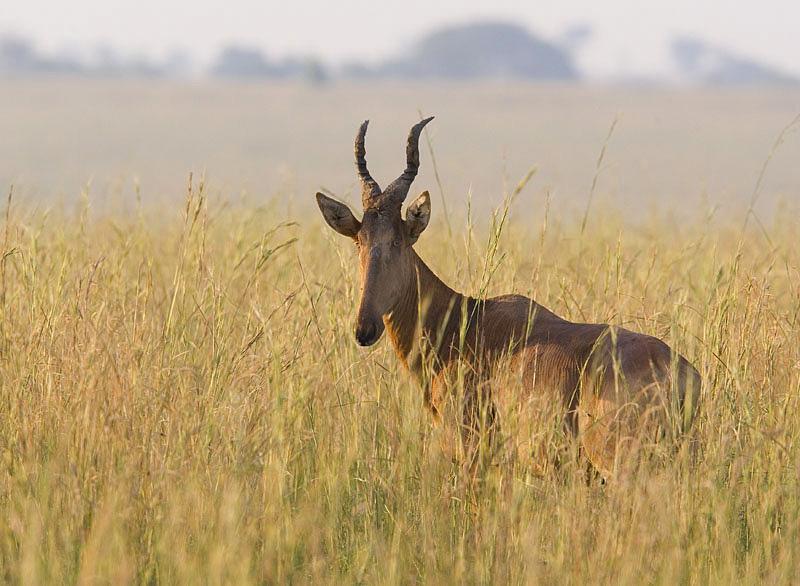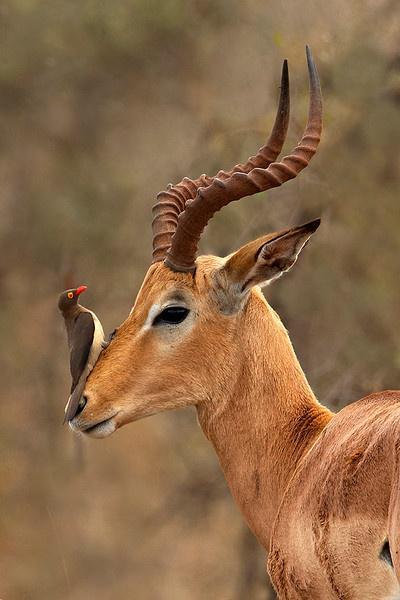The first image is the image on the left, the second image is the image on the right. Assess this claim about the two images: "There is exactly one animal in the image on the right.". Correct or not? Answer yes or no. No. 